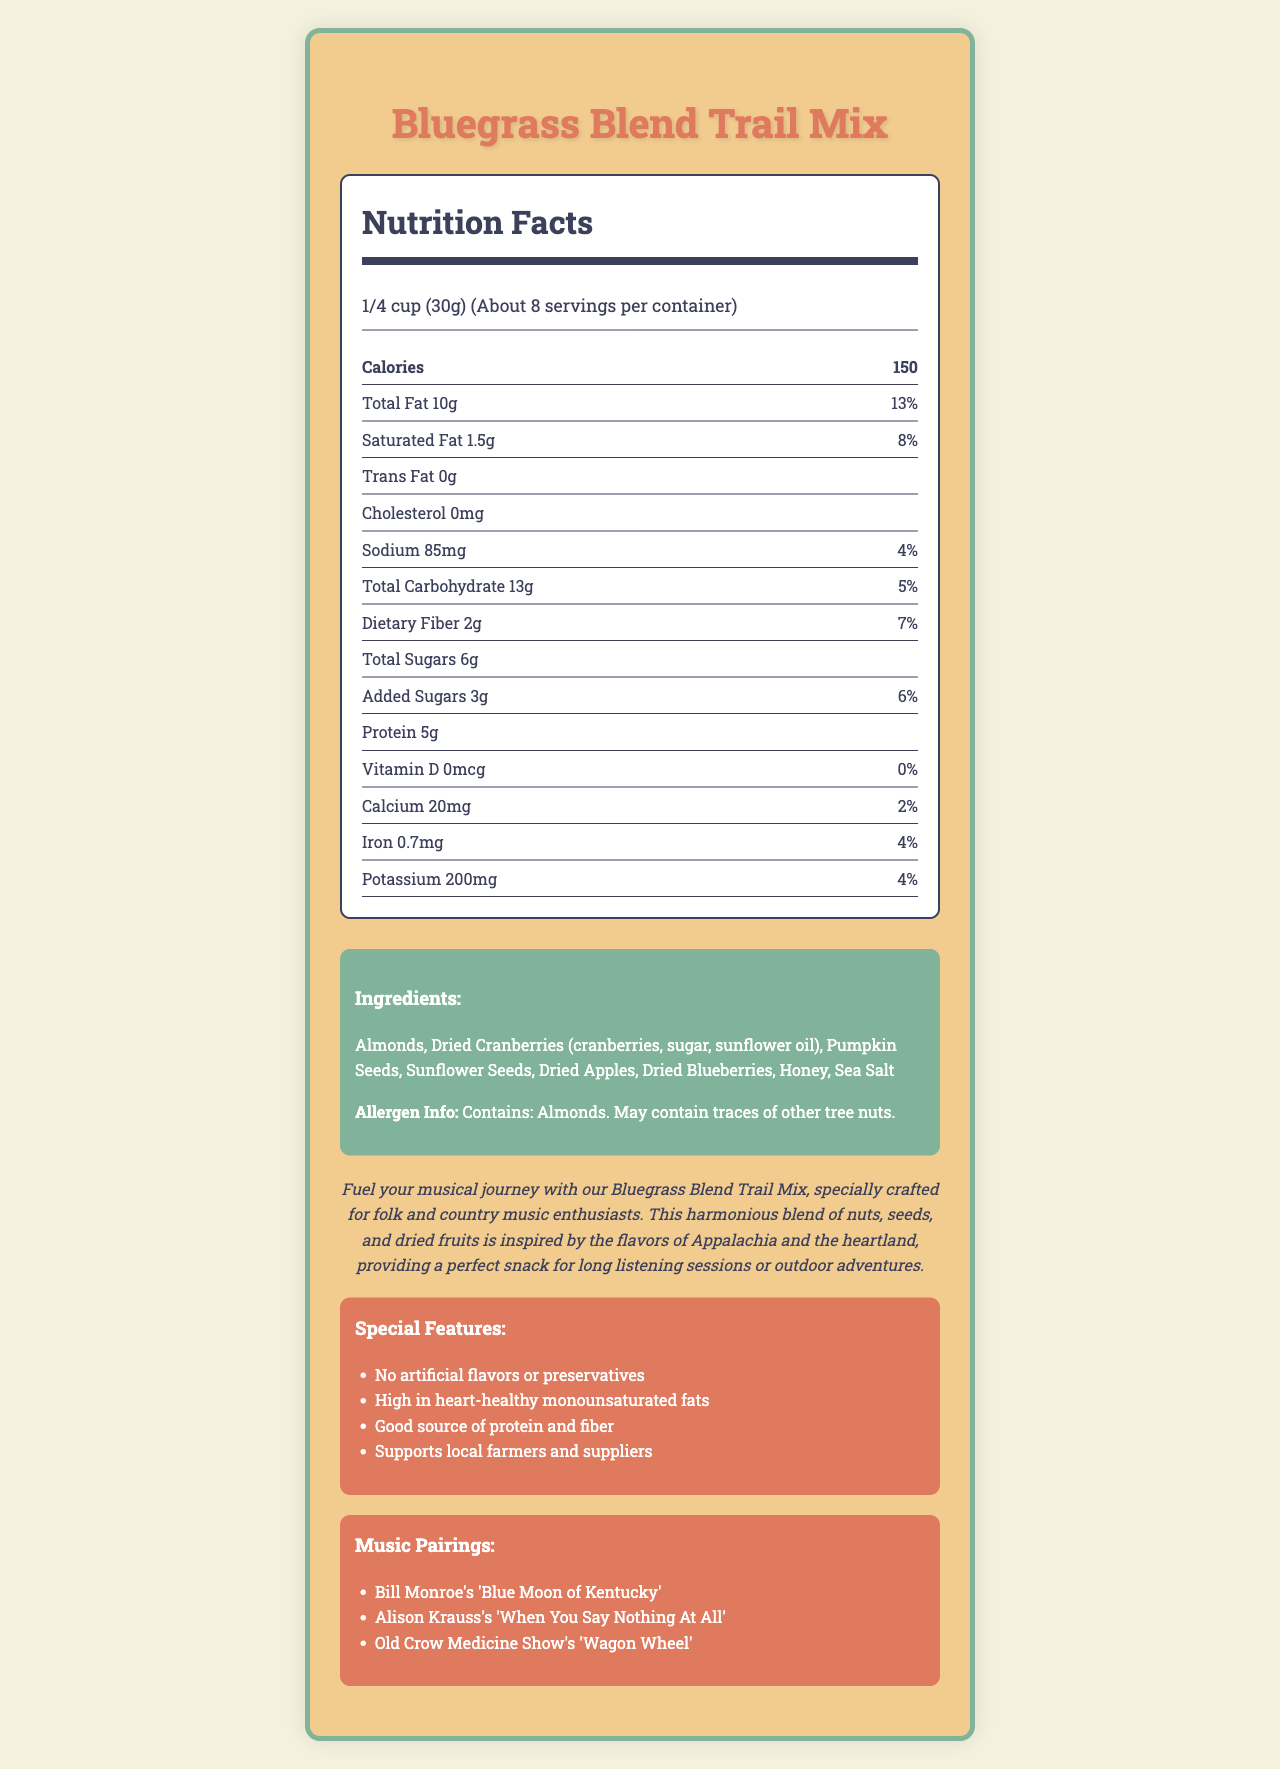what is the serving size for the Bluegrass Blend Trail Mix? The document states that the serving size is 1/4 cup, which is equivalent to 30 grams.
Answer: 1/4 cup (30g) how many servings are there per container? The document indicates that there are about 8 servings per container.
Answer: About 8 how many grams of total fat are in one serving? The nutrition facts section mentions that there is a total of 10 grams of fat per serving.
Answer: 10g how much protein is in each serving? The nutrition facts indicate that there are 5 grams of protein per serving.
Answer: 5g what is the amount of added sugars in one serving? According to the document, each serving contains 3 grams of added sugars.
Answer: 3g which ingredient provides the source of dietary fiber in this trail mix? The ingredients that contribute to dietary fiber include pumpkin seeds, sunflower seeds, and dried apples as they are common sources of fiber.
Answer: Pumpkin Seeds, Sunflower Seeds, Dried Apples what is the percentage of daily value for saturated fat? The nutrition facts specify that the daily value percentage for saturated fat is 8%.
Answer: 8% how many milligrams of calcium are in one serving? A. 30mg B. 20mg C. 50mg D. 10mg The document states that there are 20 milligrams of calcium per serving, which is 2% of the daily value.
Answer: B. 20mg which song is recommended to pair with the Bluegrass Blend Trail Mix? A. "Blue Moon of Kentucky" B. "Faded Love" C. "Man of Constant Sorrow" One of the music pairings listed in the document is Bill Monroe's "Blue Moon of Kentucky."
Answer: A. "Blue Moon of Kentucky" is there any cholesterol in the Bluegrass Blend Trail Mix? The document specifies that the cholesterol content is 0mg, meaning there is no cholesterol in the trail mix.
Answer: No does the Bluegrass Blend Trail Mix contain any artificial flavors or preservatives? The special features section clarifies that the trail mix contains no artificial flavors or preservatives.
Answer: No summarize the main idea of the document This summary captures the essence of the document by mentioning the crucial details: nutritional information, ingredients, allergen info, special features, and the marketing strategy related to folk and country music.
Answer: The document is a detailed description of the Bluegrass Blend Trail Mix, including its nutritional facts, ingredients, allergen information, and special features. It highlights the mix's connection to folk and country music by providing music pairings and emphasizes its wholesome and natural ingredients. is the Bluegrass Blend Trail Mix suitable for someone with a tree nut allergy? The allergen information clearly states that the trail mix contains almonds and may also contain traces of other tree nuts.
Answer: No does the trail mix support local farmers? A. Yes B. No C. Not mentioned The special features mention that the trail mix is made with ingredients that support local farmers and suppliers.
Answer: A. Yes how much potassium is in one serving of the Bluegrass Blend Trail Mix? The nutrition facts state that there are 200 milligrams of potassium in each serving.
Answer: 200mg can you determine where the trail mix is produced from this document? The document does not provide any information about the production location of the trail mix.
Answer: Not enough information 